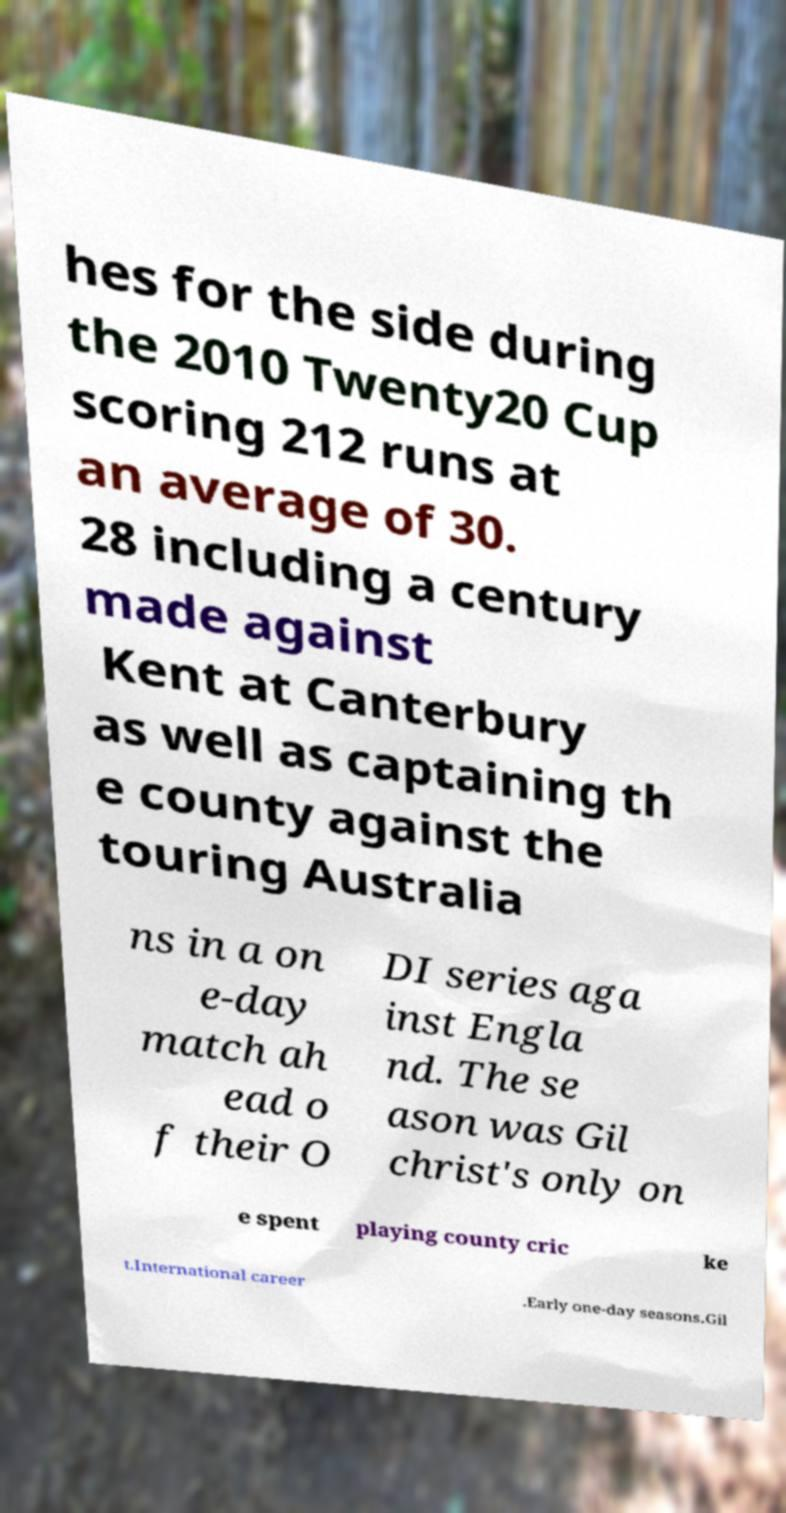Could you extract and type out the text from this image? hes for the side during the 2010 Twenty20 Cup scoring 212 runs at an average of 30. 28 including a century made against Kent at Canterbury as well as captaining th e county against the touring Australia ns in a on e-day match ah ead o f their O DI series aga inst Engla nd. The se ason was Gil christ's only on e spent playing county cric ke t.International career .Early one-day seasons.Gil 